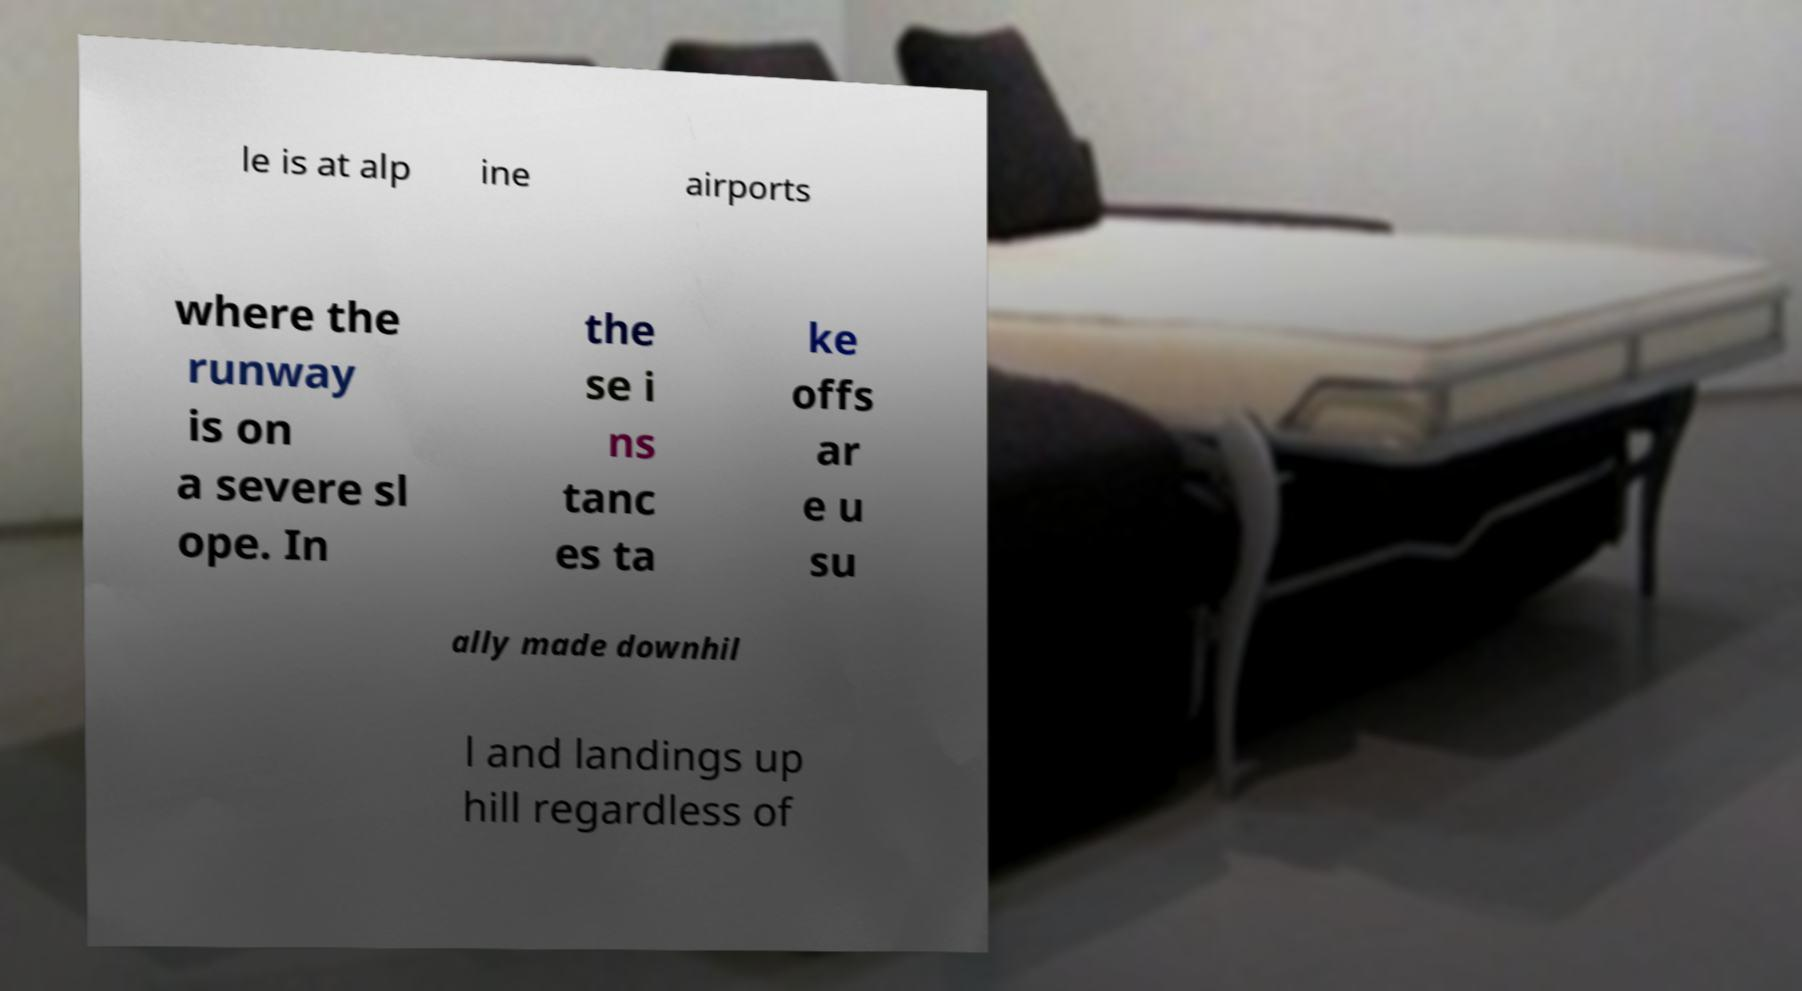Can you accurately transcribe the text from the provided image for me? le is at alp ine airports where the runway is on a severe sl ope. In the se i ns tanc es ta ke offs ar e u su ally made downhil l and landings up hill regardless of 